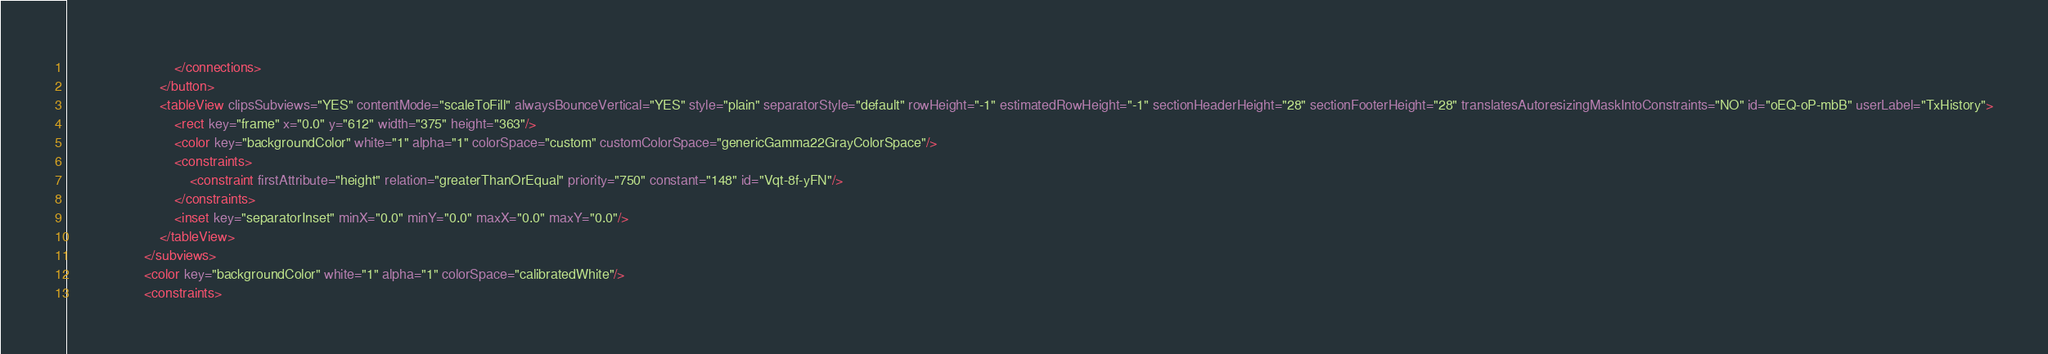Convert code to text. <code><loc_0><loc_0><loc_500><loc_500><_XML_>                            </connections>
                        </button>
                        <tableView clipsSubviews="YES" contentMode="scaleToFill" alwaysBounceVertical="YES" style="plain" separatorStyle="default" rowHeight="-1" estimatedRowHeight="-1" sectionHeaderHeight="28" sectionFooterHeight="28" translatesAutoresizingMaskIntoConstraints="NO" id="oEQ-oP-mbB" userLabel="TxHistory">
                            <rect key="frame" x="0.0" y="612" width="375" height="363"/>
                            <color key="backgroundColor" white="1" alpha="1" colorSpace="custom" customColorSpace="genericGamma22GrayColorSpace"/>
                            <constraints>
                                <constraint firstAttribute="height" relation="greaterThanOrEqual" priority="750" constant="148" id="Vqt-8f-yFN"/>
                            </constraints>
                            <inset key="separatorInset" minX="0.0" minY="0.0" maxX="0.0" maxY="0.0"/>
                        </tableView>
                    </subviews>
                    <color key="backgroundColor" white="1" alpha="1" colorSpace="calibratedWhite"/>
                    <constraints></code> 